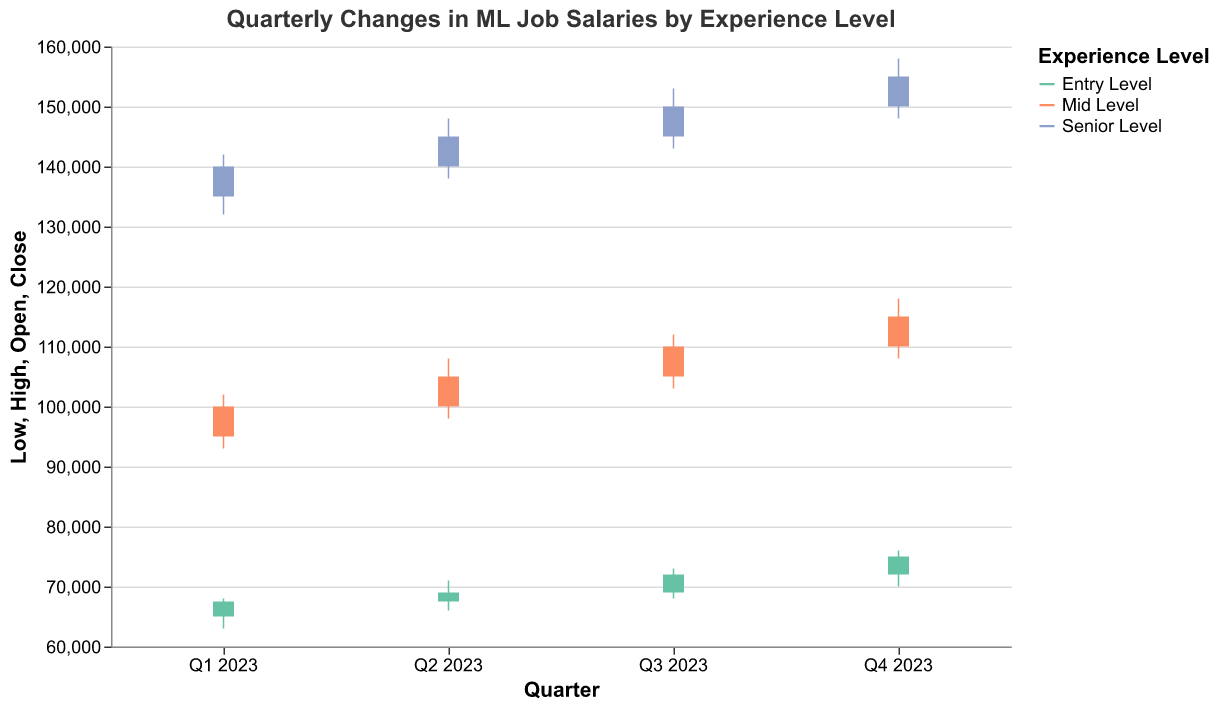What is the highest salary for Mid Level positions in Q3 2023? Refer to the bar and vertical rule marking the High value for Mid Level in Q3 2023, which is the highest point reached by the vertical line corresponding to Mid Level for that quarter.
Answer: 112000 Which experience level had the largest increase in closing salary from Q1 2023 to Q2 2023? Compare the closing values of each experience level between Q1 2023 and Q2 2023. For Entry Level, the increase is from 67500 to 69000 (1500), for Mid Level it's from 100000 to 105000 (5000), and for Senior Level it's from 140000 to 145000 (5000). Both Mid Level and Senior Level had the largest increase of 5000.
Answer: Mid Level and Senior Level What is the average closing salary for Entry Level positions over all four quarters in 2023? Add the closing values for Entry Level in Q1 (67500), Q2 (69000), Q3 (72000), and Q4 (75000) and divide by the number of quarters: (67500 + 69000 + 72000 + 75000) / 4.
Answer: 70875 How does the closing salary for Senior Level positions in Q4 2023 compare to the opening salary in the same quarter? Compare the closing value (155000) to the opening value (150000) for Senior Level in Q4 2023 by referring to the bar segments.
Answer: It is higher by 5000 Which quarter shows the highest closing salary for Mid Level positions? Examine the 'Close' values for Mid Level across all quarters; Q4 2023 has the highest closing salary.
Answer: Q4 2023 In which quarter did the Entry Level positions experience the largest range between High and Low salaries? Calculate the High - Low for Entry Level in each quarter: Q1 (68000 - 63000 = 5000), Q2 (71000 - 66000 = 5000), Q3 (73000 - 68000 = 5000), and Q4 (76000 - 70000 = 6000).
Answer: Q4 2023 What was the closing salary trend for Entry Level positions over the four quarters of 2023? Observe the closing values for Entry Level in each quarter: Q1 (67500), Q2 (69000), Q3 (72000), Q4 (75000). The values show an increasing trend.
Answer: Increasing What is the difference in closing salaries between Entry Level and Senior Level positions in Q4 2023? Subtract the closing value for Entry Level in Q4 (75000) from the closing value for Senior Level in Q4 (155000): 155000 - 75000.
Answer: 80000 Which experience level experienced the smallest difference between opening and closing salaries in Q2 2023? Calculate the absolute differences for each level in Q2: Entry Level (69000 - 67500 = 1500), Mid Level (105000 - 100000 = 5000), Senior Level (145000 - 140000 = 5000). Entry Level has the smallest difference.
Answer: Entry Level How did the high salaries for Senior Level positions change from Q1 2023 to Q4 2023? Compare the High values for Senior Level from Q1 (142000) to Q4 (158000).
Answer: Increased by 16000 